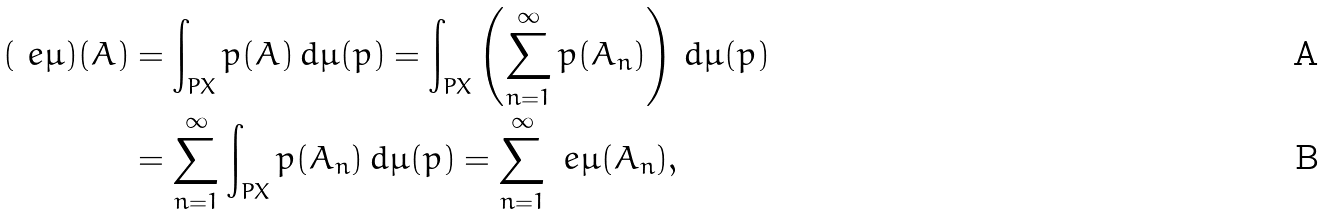Convert formula to latex. <formula><loc_0><loc_0><loc_500><loc_500>( \ e \mu ) ( A ) & = \int _ { P X } p ( A ) \, d \mu ( p ) = \int _ { P X } \left ( \sum _ { n = 1 } ^ { \infty } p ( A _ { n } ) \right ) \, d \mu ( p ) \\ & = \sum _ { n = 1 } ^ { \infty } \int _ { P X } p ( A _ { n } ) \, d \mu ( p ) = \sum _ { n = 1 } ^ { \infty } \ e \mu ( A _ { n } ) ,</formula> 